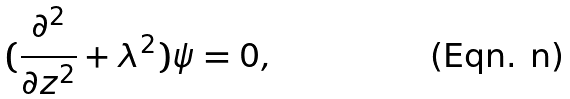Convert formula to latex. <formula><loc_0><loc_0><loc_500><loc_500>( \frac { \partial ^ { 2 } } { \partial z ^ { 2 } } + \lambda ^ { 2 } ) \psi = 0 ,</formula> 